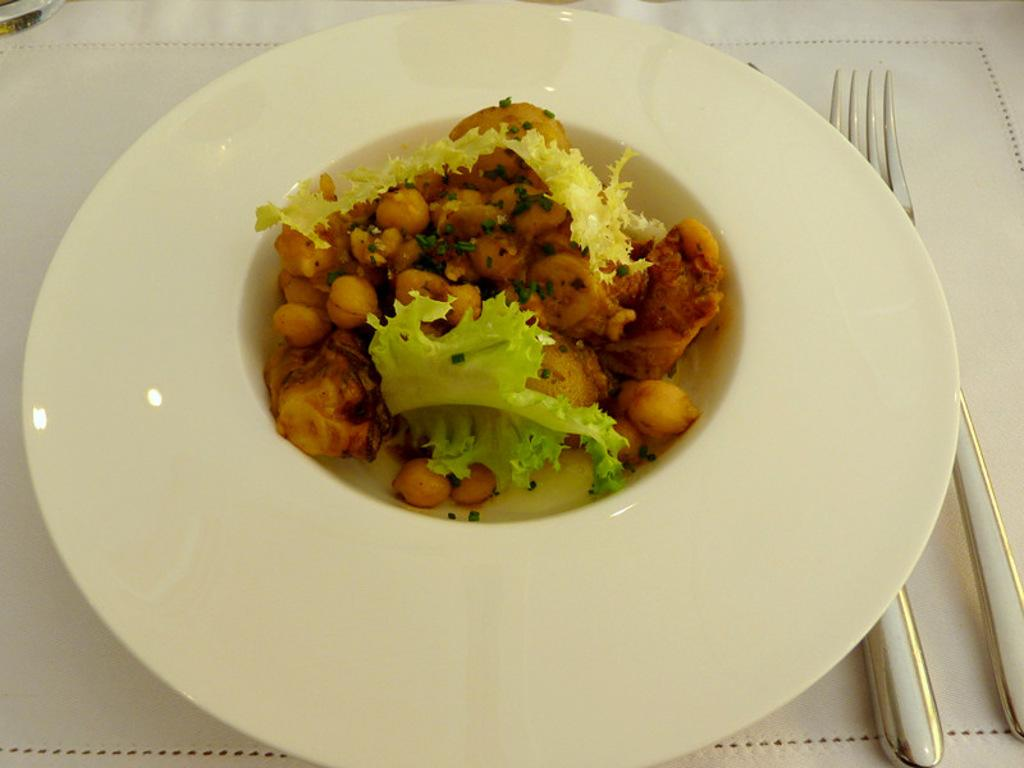What is on the plate that is visible in the image? There is food on a plate in the image. Where is the plate located in the image? The plate is in the center of the image. What is present on the right side of the plate? There are folks on the right side of the plate. What type of connection is being made by the doctor in the image? There is no doctor present in the image, so it is not possible to answer that question. 